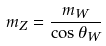<formula> <loc_0><loc_0><loc_500><loc_500>m _ { Z } = \frac { m _ { W } } { \cos \theta _ { W } }</formula> 